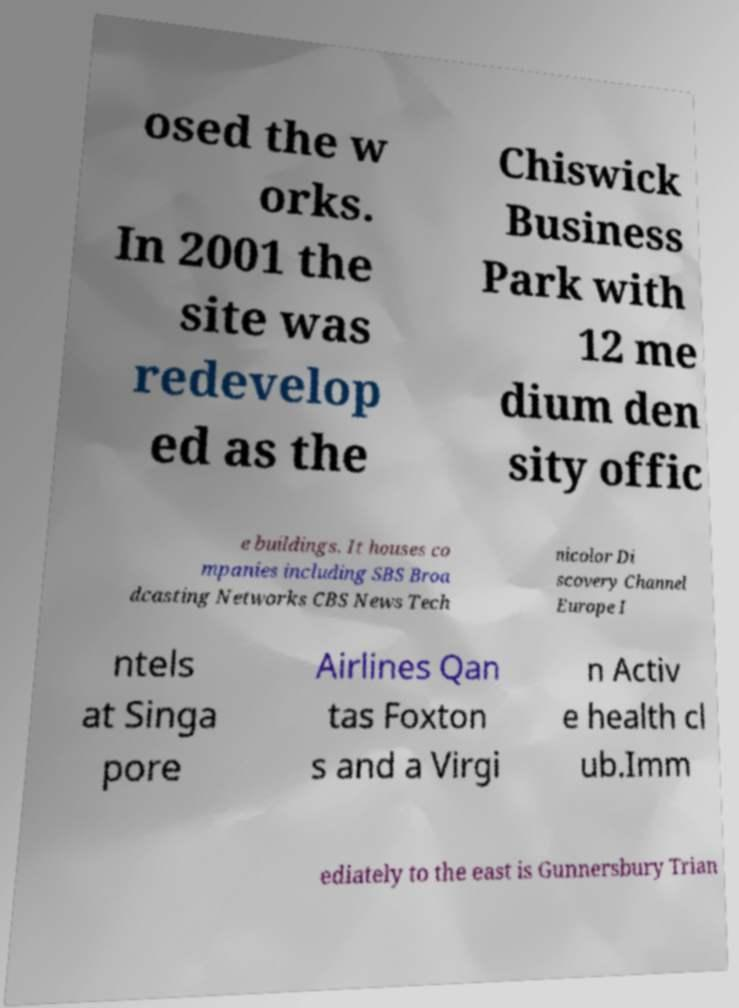Could you assist in decoding the text presented in this image and type it out clearly? osed the w orks. In 2001 the site was redevelop ed as the Chiswick Business Park with 12 me dium den sity offic e buildings. It houses co mpanies including SBS Broa dcasting Networks CBS News Tech nicolor Di scovery Channel Europe I ntels at Singa pore Airlines Qan tas Foxton s and a Virgi n Activ e health cl ub.Imm ediately to the east is Gunnersbury Trian 